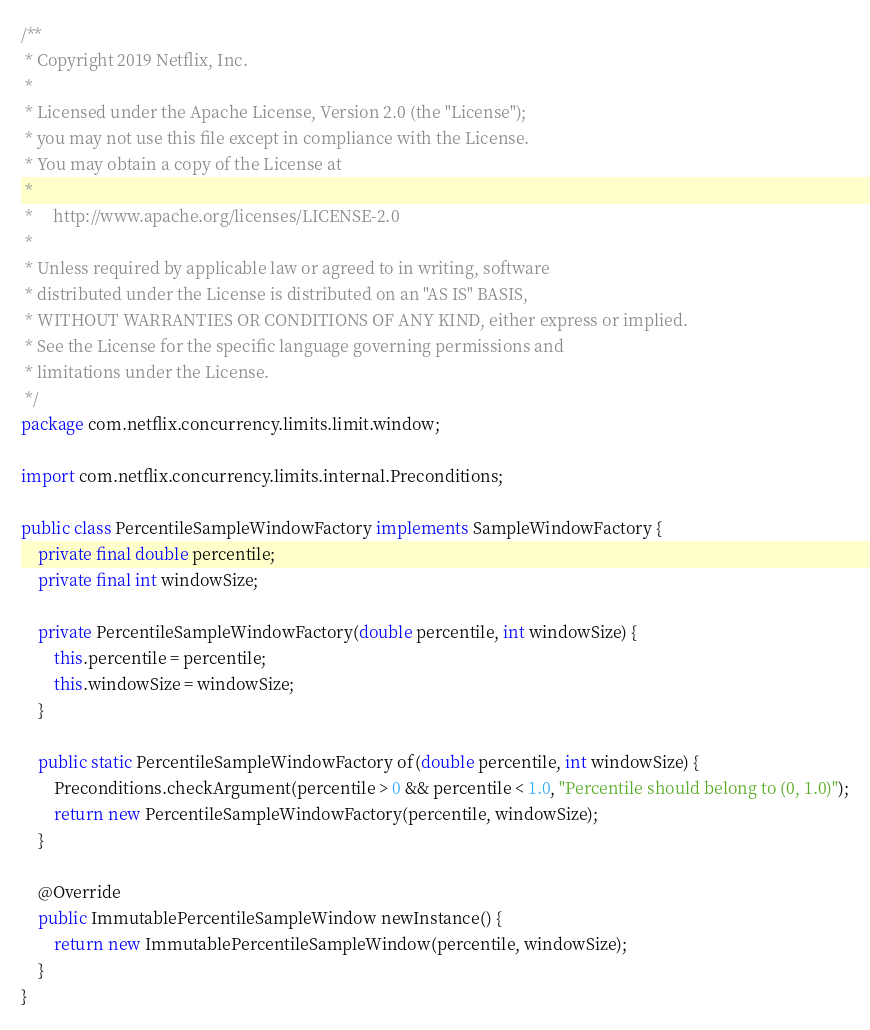Convert code to text. <code><loc_0><loc_0><loc_500><loc_500><_Java_>/**
 * Copyright 2019 Netflix, Inc.
 *
 * Licensed under the Apache License, Version 2.0 (the "License");
 * you may not use this file except in compliance with the License.
 * You may obtain a copy of the License at
 *
 *     http://www.apache.org/licenses/LICENSE-2.0
 *
 * Unless required by applicable law or agreed to in writing, software
 * distributed under the License is distributed on an "AS IS" BASIS,
 * WITHOUT WARRANTIES OR CONDITIONS OF ANY KIND, either express or implied.
 * See the License for the specific language governing permissions and
 * limitations under the License.
 */
package com.netflix.concurrency.limits.limit.window;

import com.netflix.concurrency.limits.internal.Preconditions;

public class PercentileSampleWindowFactory implements SampleWindowFactory {
    private final double percentile;
    private final int windowSize;

    private PercentileSampleWindowFactory(double percentile, int windowSize) {
        this.percentile = percentile;
        this.windowSize = windowSize;
    }

    public static PercentileSampleWindowFactory of(double percentile, int windowSize) {
        Preconditions.checkArgument(percentile > 0 && percentile < 1.0, "Percentile should belong to (0, 1.0)");
        return new PercentileSampleWindowFactory(percentile, windowSize);
    }

    @Override
    public ImmutablePercentileSampleWindow newInstance() {
        return new ImmutablePercentileSampleWindow(percentile, windowSize);
    }
}
</code> 